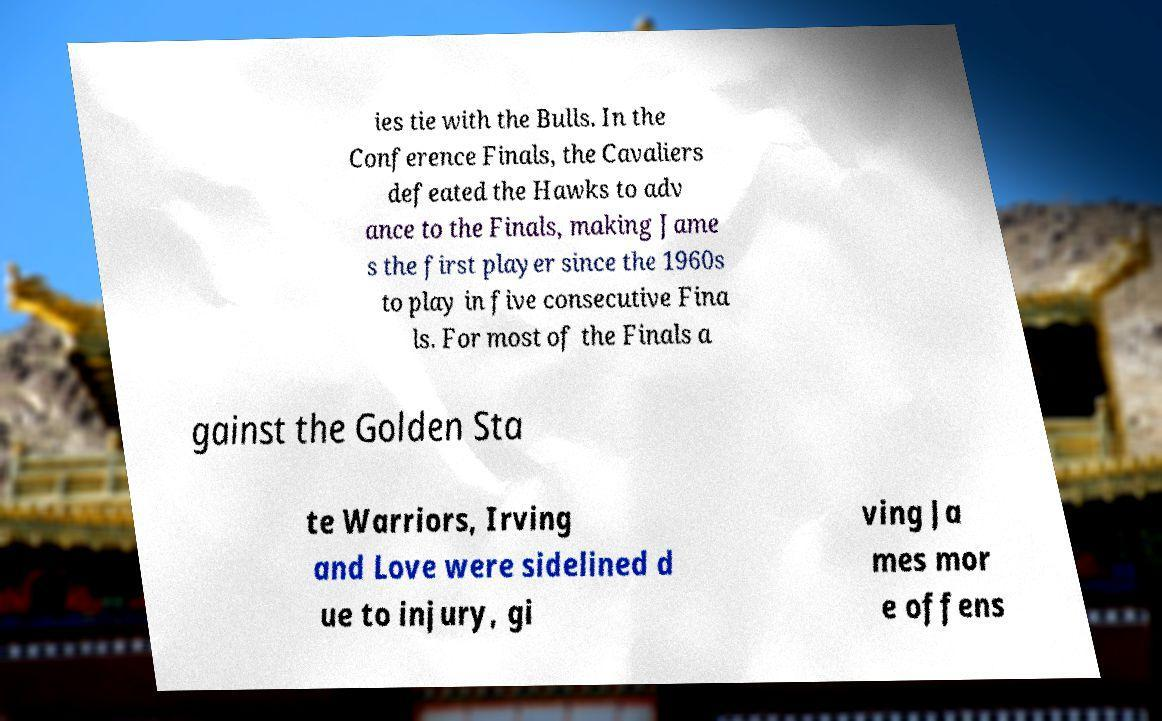Can you accurately transcribe the text from the provided image for me? ies tie with the Bulls. In the Conference Finals, the Cavaliers defeated the Hawks to adv ance to the Finals, making Jame s the first player since the 1960s to play in five consecutive Fina ls. For most of the Finals a gainst the Golden Sta te Warriors, Irving and Love were sidelined d ue to injury, gi ving Ja mes mor e offens 